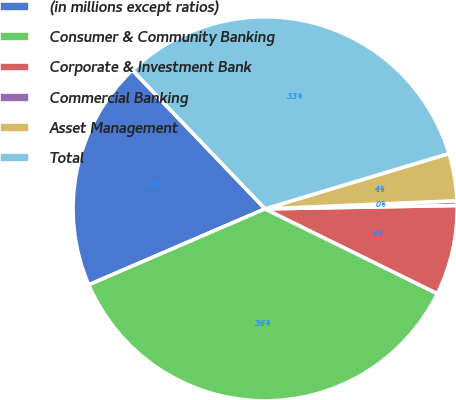<chart> <loc_0><loc_0><loc_500><loc_500><pie_chart><fcel>(in millions except ratios)<fcel>Consumer & Community Banking<fcel>Corporate & Investment Bank<fcel>Commercial Banking<fcel>Asset Management<fcel>Total<nl><fcel>19.32%<fcel>36.24%<fcel>7.56%<fcel>0.39%<fcel>3.98%<fcel>32.5%<nl></chart> 